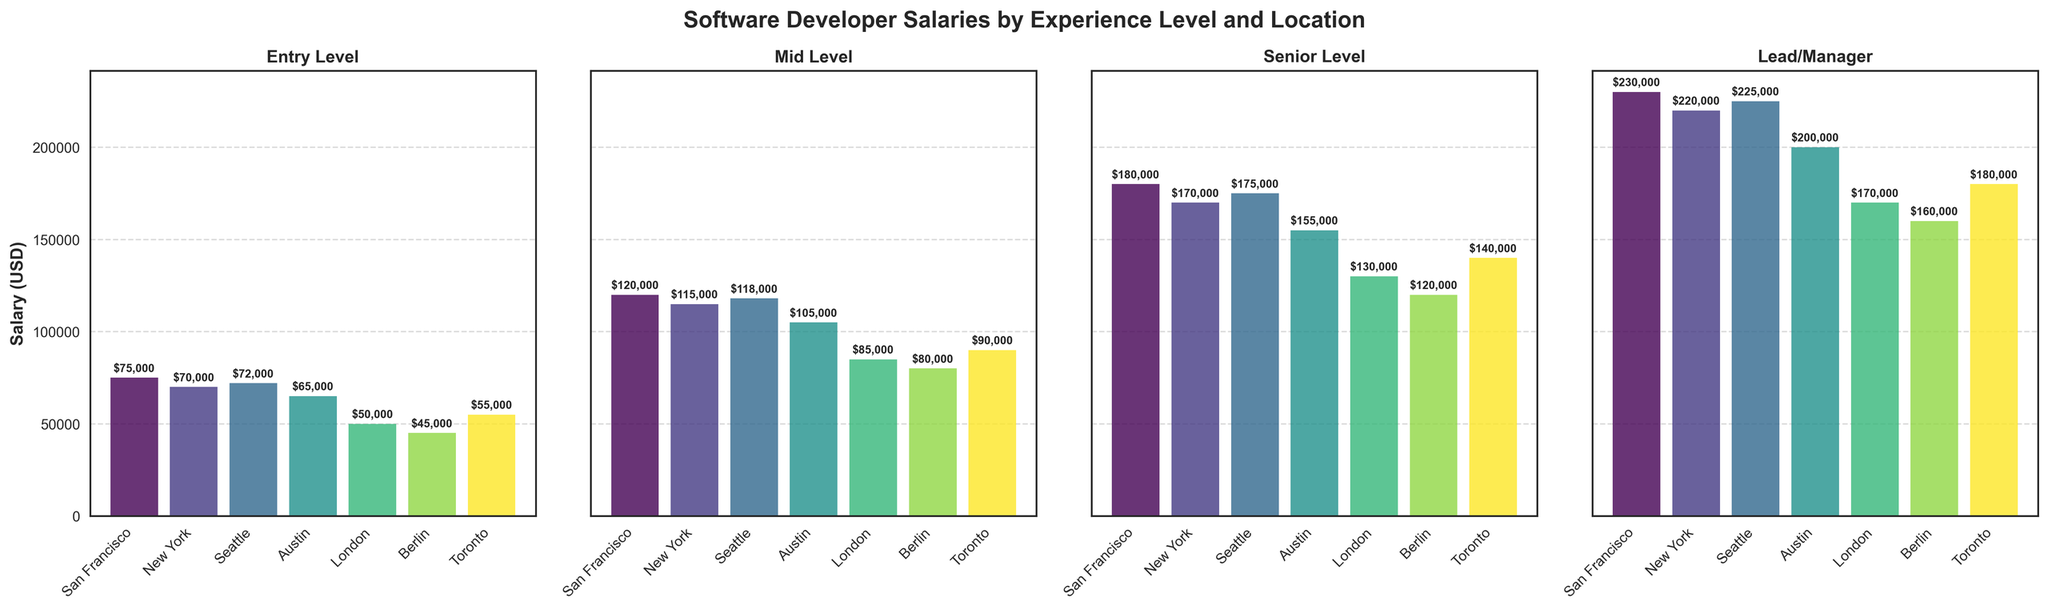What is the average salary for Mid Level software developers across all locations? To find the average salary for Mid Level software developers, sum up the Mid Level salaries and divide by the number of locations. ($120,000 + $115,000 + $118,000 + $105,000 + $85,000 + $80,000 + $90,000) / 7 = $713,000 / 7 = $101,857
Answer: $101,857 Which location has the highest salary for Senior Level software developers? Look at the bar heights for the Senior Level subplot and identify the tallest bar. The highest bar corresponds to "San Francisco" with a salary of $180,000
Answer: San Francisco How much more does an Entry Level developer earn in San Francisco compared to Berlin? Look at the Entry Level subplot bars for San Francisco and Berlin. Subtract Berlin's salary from San Francisco's salary: $75,000 - $45,000 = $30,000
Answer: $30,000 What is the difference between the highest and lowest salary for Lead/Manager positions? Find the heights of the tallest and shortest bars in the Lead/Manager subplot. Subtract the lowest value from the highest value: $230,000 (San Francisco) - $160,000 (Berlin) = $70,000
Answer: $70,000 Which experience level has the most uniform distribution of salaries across all locations? Compare the spread of bar heights across each subplot. Entry Level appears to have the most uniform heights, indicating more consistent salaries across different locations.
Answer: Entry Level Are there any locations where the salary for Mid Level developers is higher than for Senior Level developers? Compare the bar heights in the Mid Level and Senior Level subplots for each location. No location has Mid Level salaries higher than Senior Level salaries.
Answer: No Which location shows the largest salary growth from Entry Level to Lead/Manager? For each location, calculate the difference between the Entry Level and Lead/Manager salaries and identify the largest difference. San Francisco has $230,000 (Lead/Manager) - $75,000 (Entry Level) = $155,000
Answer: San Francisco How does the salary of a Mid Level developer in London compare to a Senior Level developer in Toronto? Compare the bar heights in the Mid Level subplot for London and the Senior Level subplot for Toronto. London Mid Level is $85,000 and Toronto Senior Level is $140,000. The salary in London is lower by $140,000 - $85,000 = $55,000.
Answer: London is $55,000 lower What is the total salary difference between Entry Level and Senior Level developers in Austin? Look at the Austin bars in the Entry Level and Senior Level subplots. Subtract the Entry Level salary from the Senior Level salary: $155,000 - $65,000 = $90,000
Answer: $90,000 Which two locations have the closest salaries for Lead/Manager positions? Compare the bar heights in the Lead/Manager subplot to find pair of bars that are closest in height. Toronto and Berlin are closest with $180,000 and $160,000 respectively, having a difference of $20,000.
Answer: Toronto and Berlin 